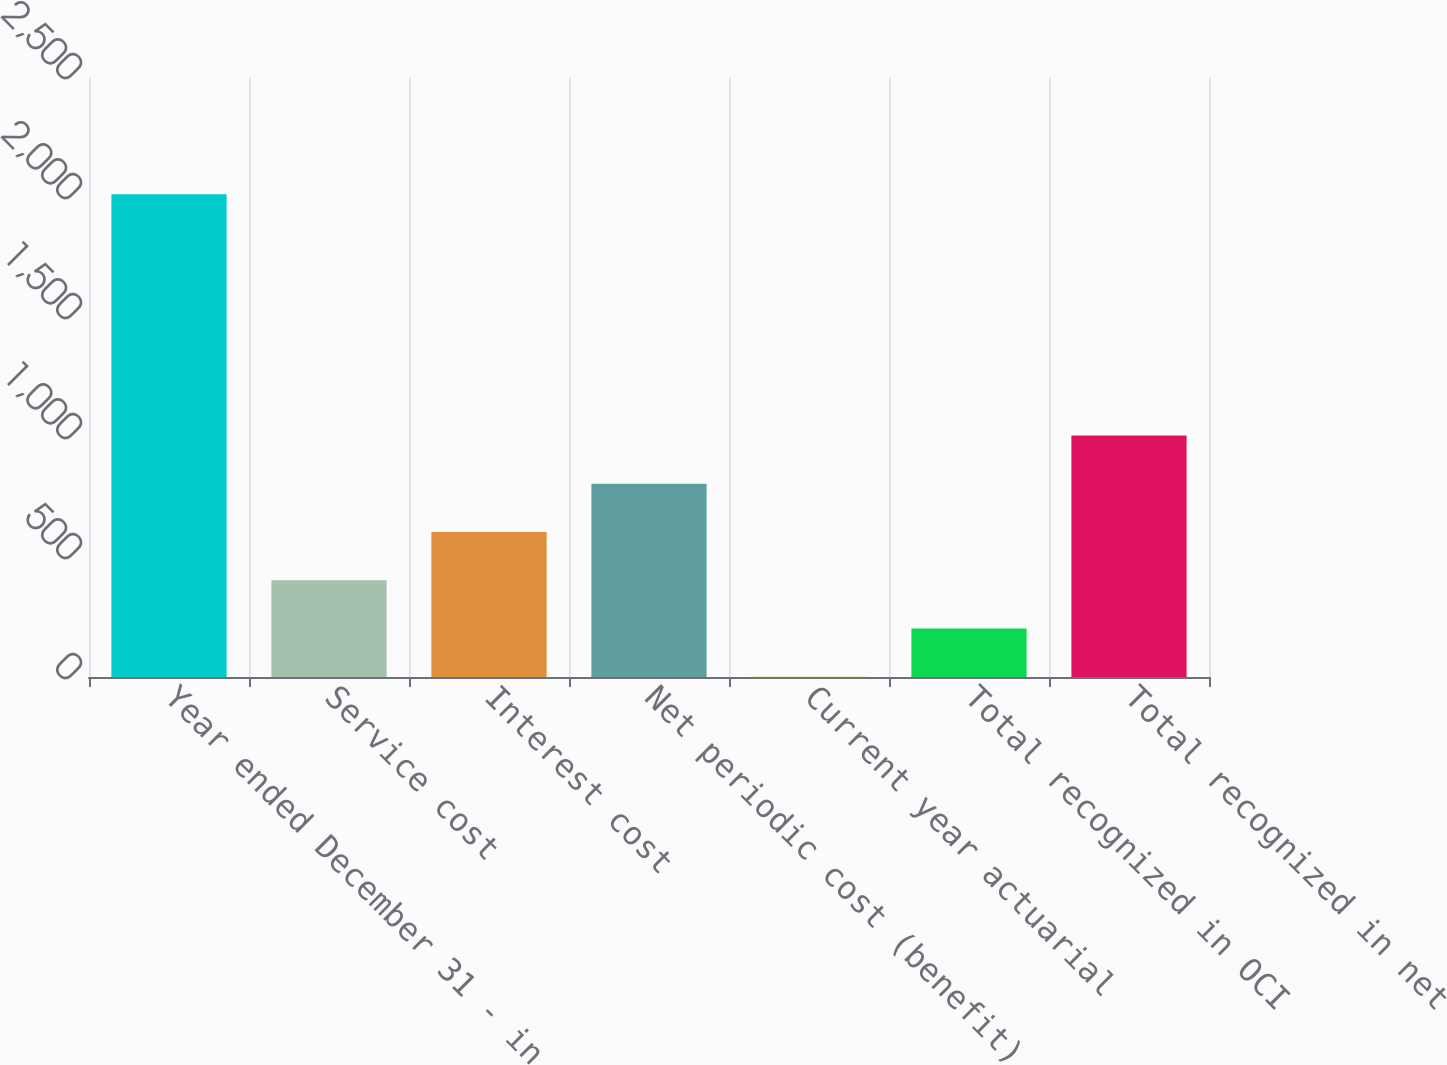Convert chart. <chart><loc_0><loc_0><loc_500><loc_500><bar_chart><fcel>Year ended December 31 - in<fcel>Service cost<fcel>Interest cost<fcel>Net periodic cost (benefit)<fcel>Current year actuarial<fcel>Total recognized in OCI<fcel>Total recognized in net<nl><fcel>2011<fcel>403<fcel>604<fcel>805<fcel>1<fcel>202<fcel>1006<nl></chart> 